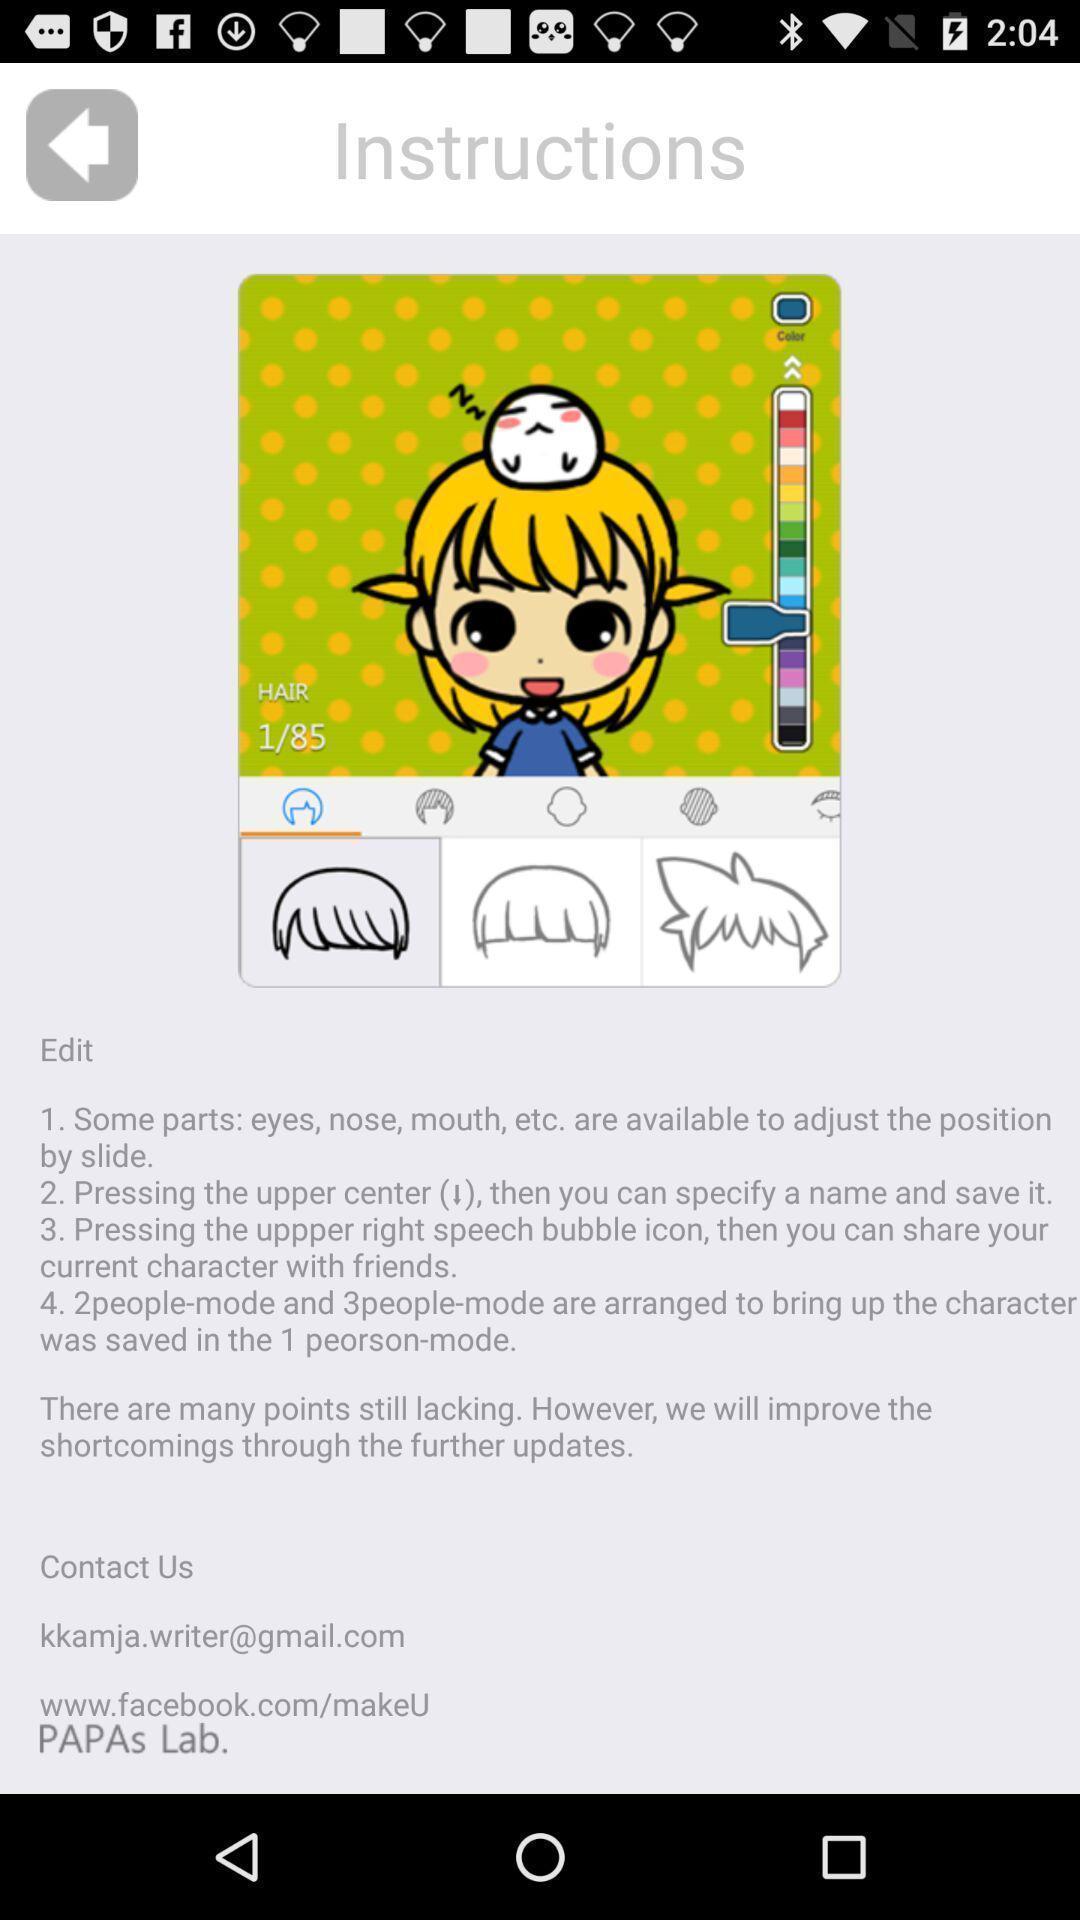Provide a detailed account of this screenshot. Result for instruction page in an social application. 